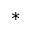<formula> <loc_0><loc_0><loc_500><loc_500>\ast</formula> 